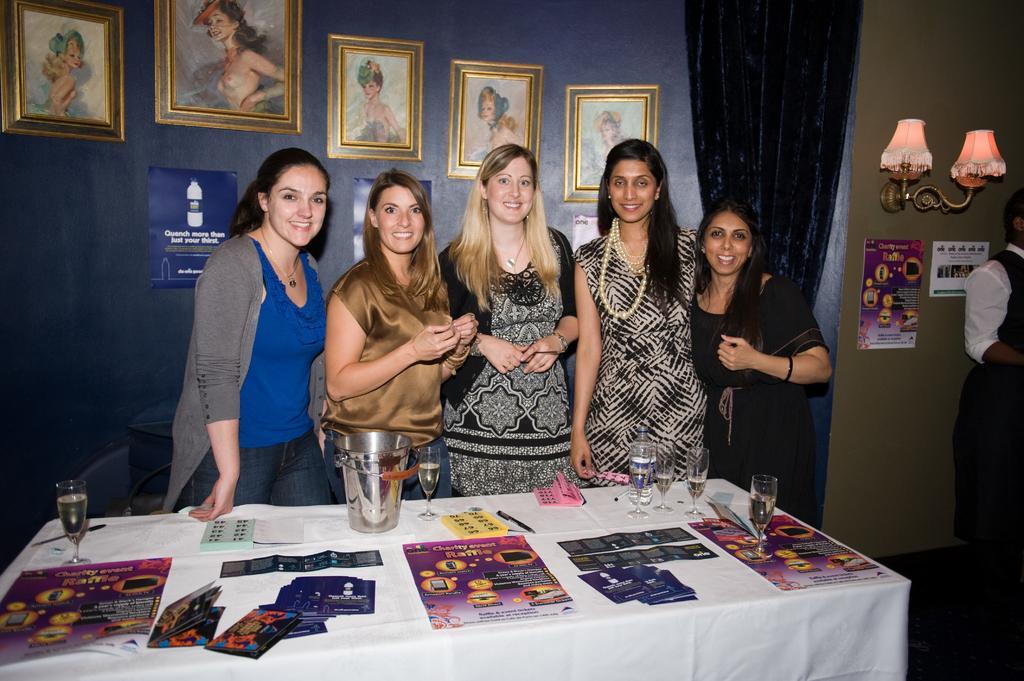Please provide a concise description of this image. In this picture we can see five women standing in front of a table, there are some posters, papers, glasses, a bucket present on the table, in the background there is a wall, we can see photo frames on the wall, on the right side we can see two lamps, there is another person standing here. 